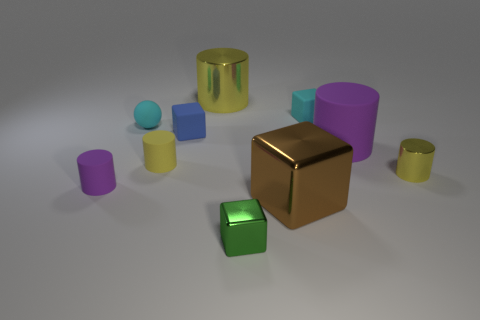Subtract all yellow cylinders. How many were subtracted if there are2yellow cylinders left? 1 Subtract all red cubes. How many yellow cylinders are left? 3 Subtract all brown shiny blocks. How many blocks are left? 3 Subtract all blocks. How many objects are left? 6 Subtract 0 gray spheres. How many objects are left? 10 Subtract all small cyan rubber spheres. Subtract all tiny green shiny objects. How many objects are left? 8 Add 9 cyan matte balls. How many cyan matte balls are left? 10 Add 5 cyan blocks. How many cyan blocks exist? 6 